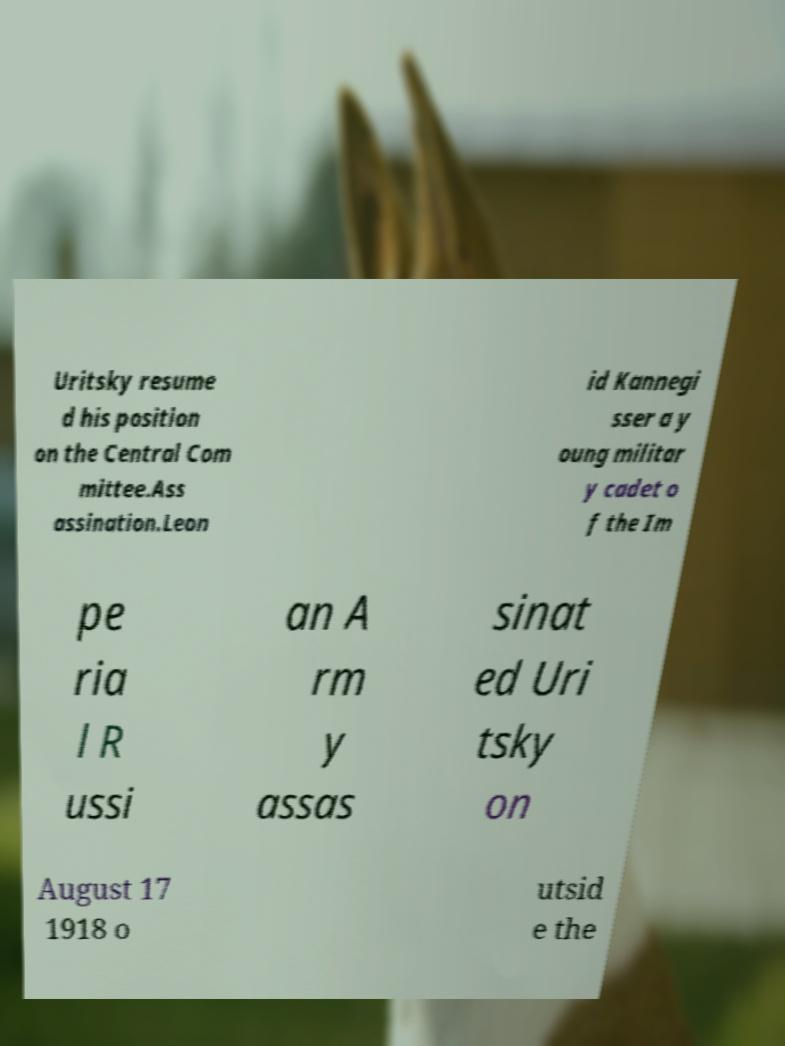Can you accurately transcribe the text from the provided image for me? Uritsky resume d his position on the Central Com mittee.Ass assination.Leon id Kannegi sser a y oung militar y cadet o f the Im pe ria l R ussi an A rm y assas sinat ed Uri tsky on August 17 1918 o utsid e the 